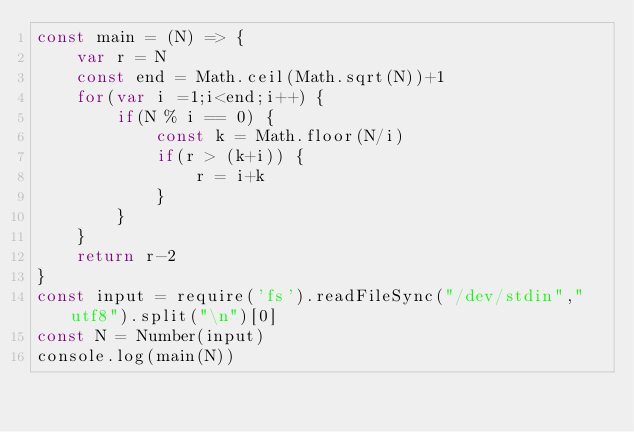<code> <loc_0><loc_0><loc_500><loc_500><_JavaScript_>const main = (N) => {
    var r = N
    const end = Math.ceil(Math.sqrt(N))+1
    for(var i =1;i<end;i++) {
        if(N % i == 0) {
            const k = Math.floor(N/i)
            if(r > (k+i)) {
                r = i+k
            }
        }
    }
    return r-2
}
const input = require('fs').readFileSync("/dev/stdin","utf8").split("\n")[0]
const N = Number(input)
console.log(main(N))</code> 